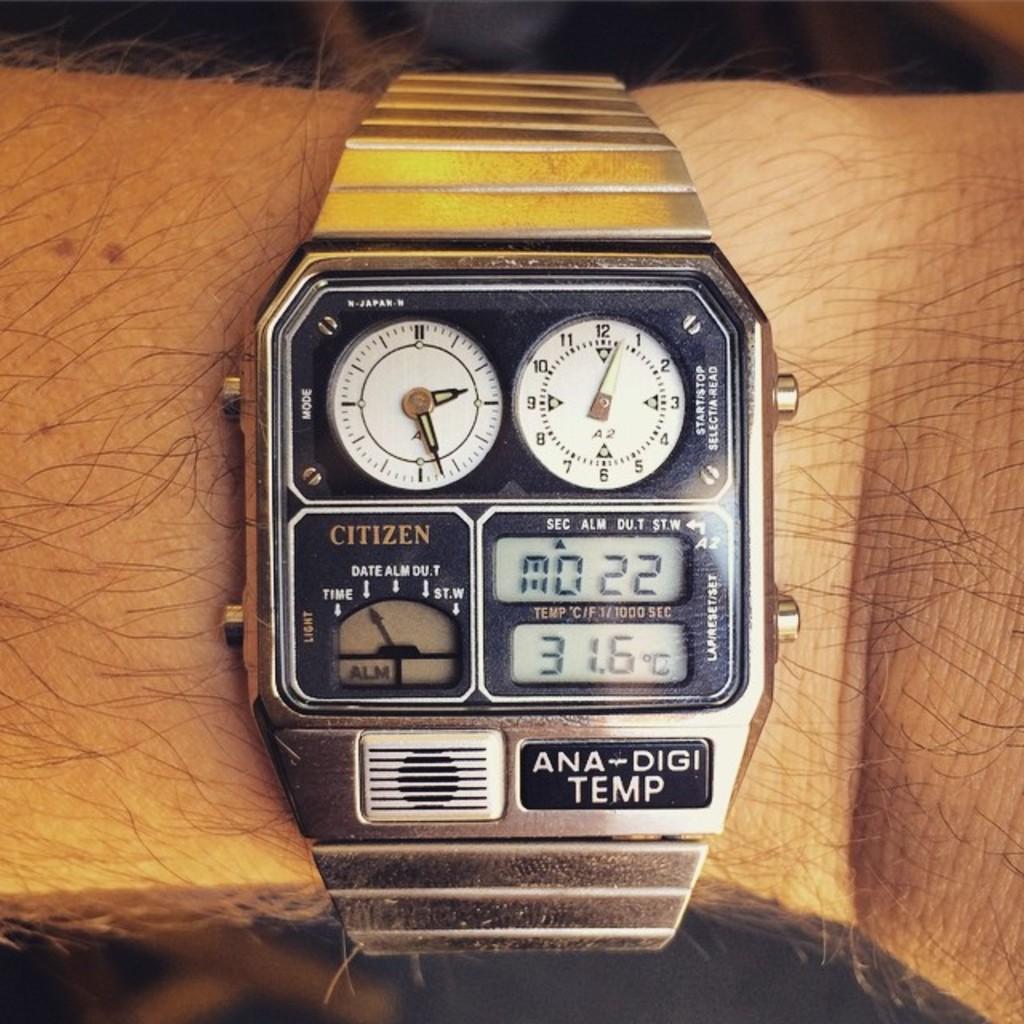Could you give a brief overview of what you see in this image? In this image we can see a person's hand with watch and the background is blurred. 